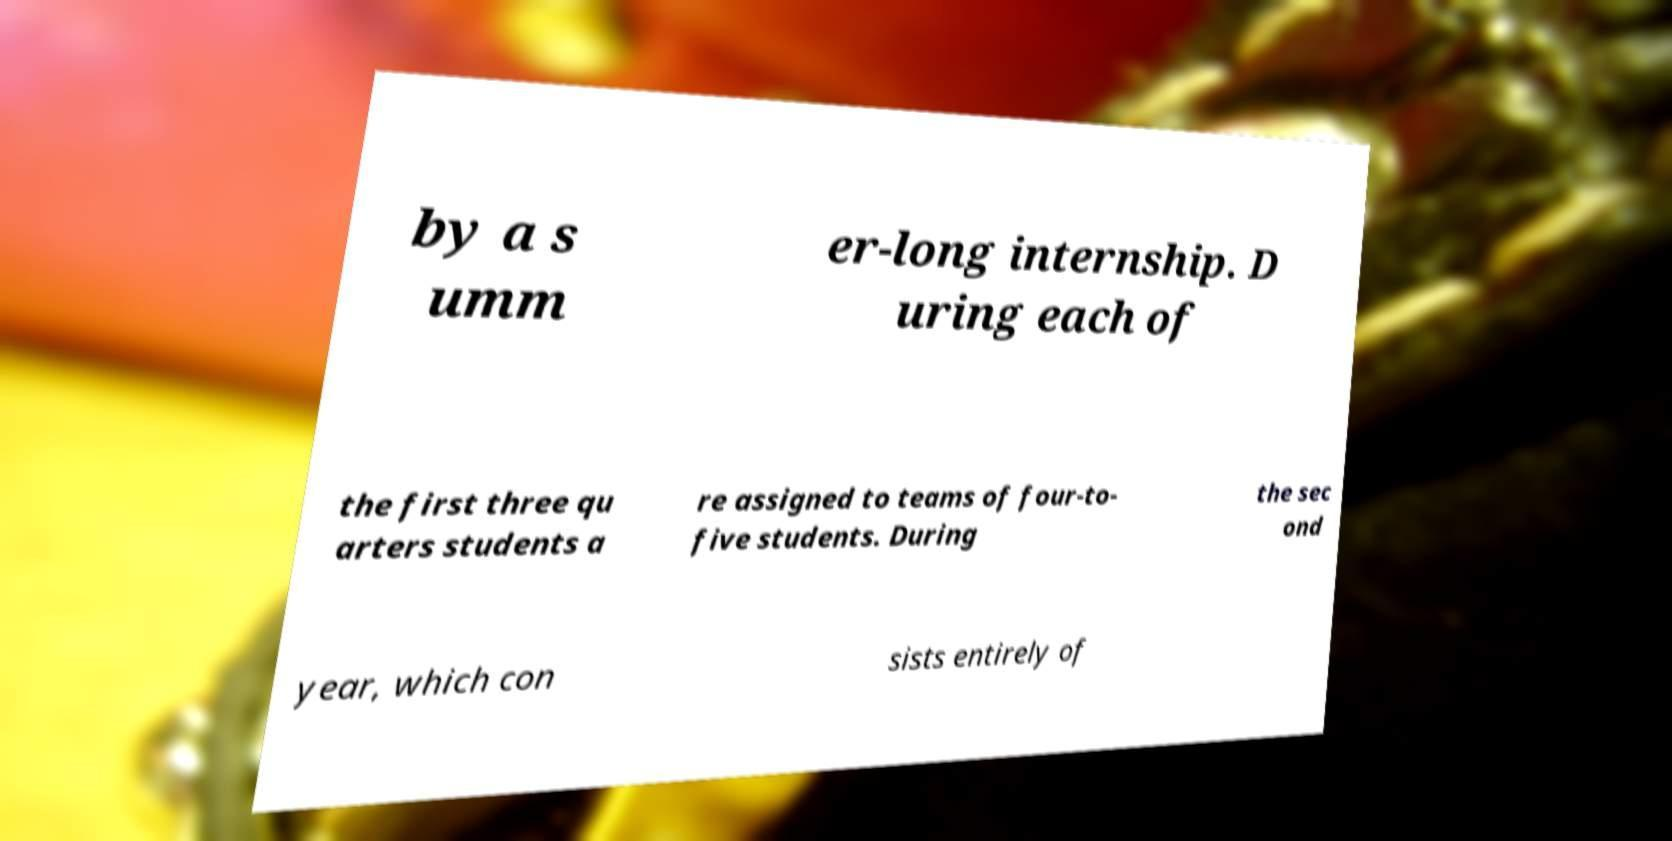Please identify and transcribe the text found in this image. by a s umm er-long internship. D uring each of the first three qu arters students a re assigned to teams of four-to- five students. During the sec ond year, which con sists entirely of 